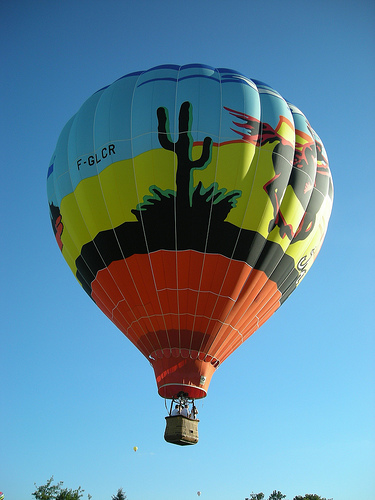<image>
Is there a cactus on the balloon? Yes. Looking at the image, I can see the cactus is positioned on top of the balloon, with the balloon providing support. 